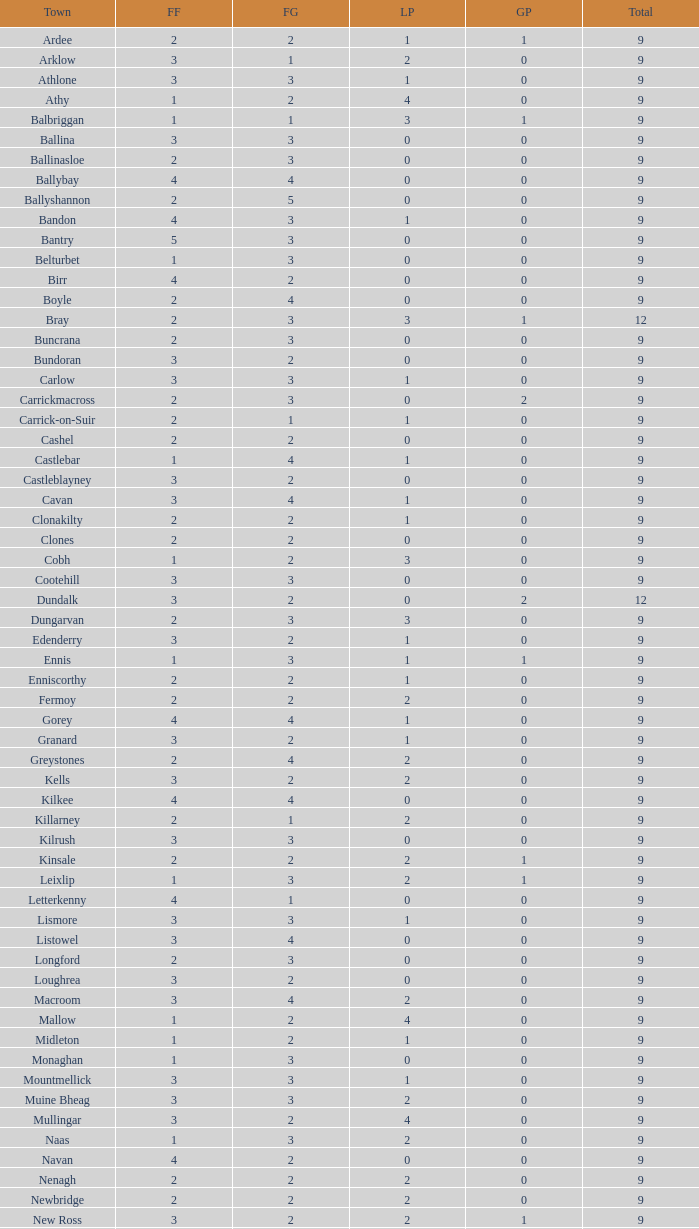What is the lowest number in the Labour Party for the Fianna Fail higher than 5? None. 